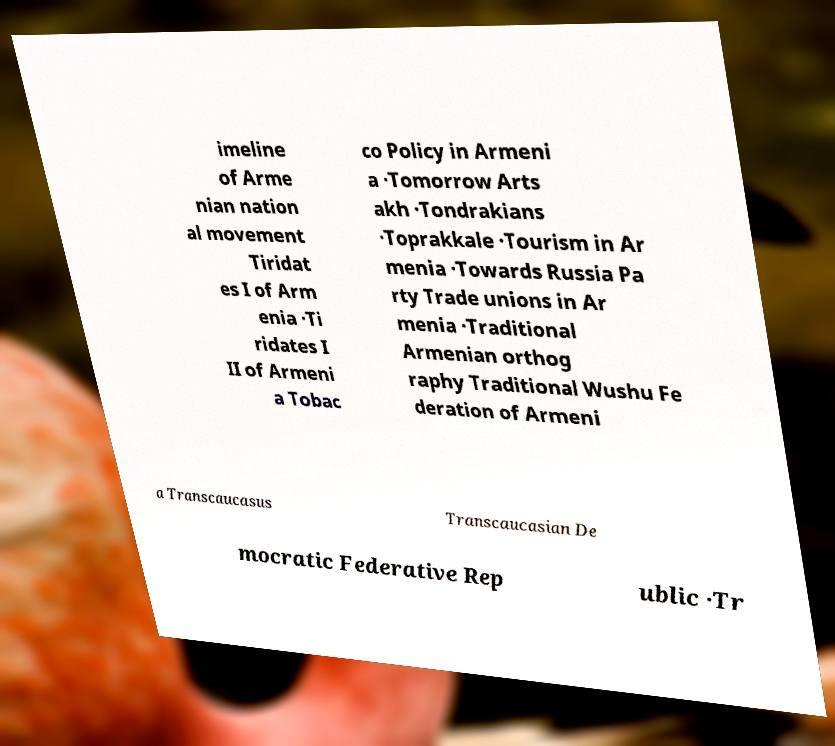Please identify and transcribe the text found in this image. imeline of Arme nian nation al movement Tiridat es I of Arm enia ·Ti ridates I II of Armeni a Tobac co Policy in Armeni a ·Tomorrow Arts akh ·Tondrakians ·Toprakkale ·Tourism in Ar menia ·Towards Russia Pa rty Trade unions in Ar menia ·Traditional Armenian orthog raphy Traditional Wushu Fe deration of Armeni a Transcaucasus Transcaucasian De mocratic Federative Rep ublic ·Tr 